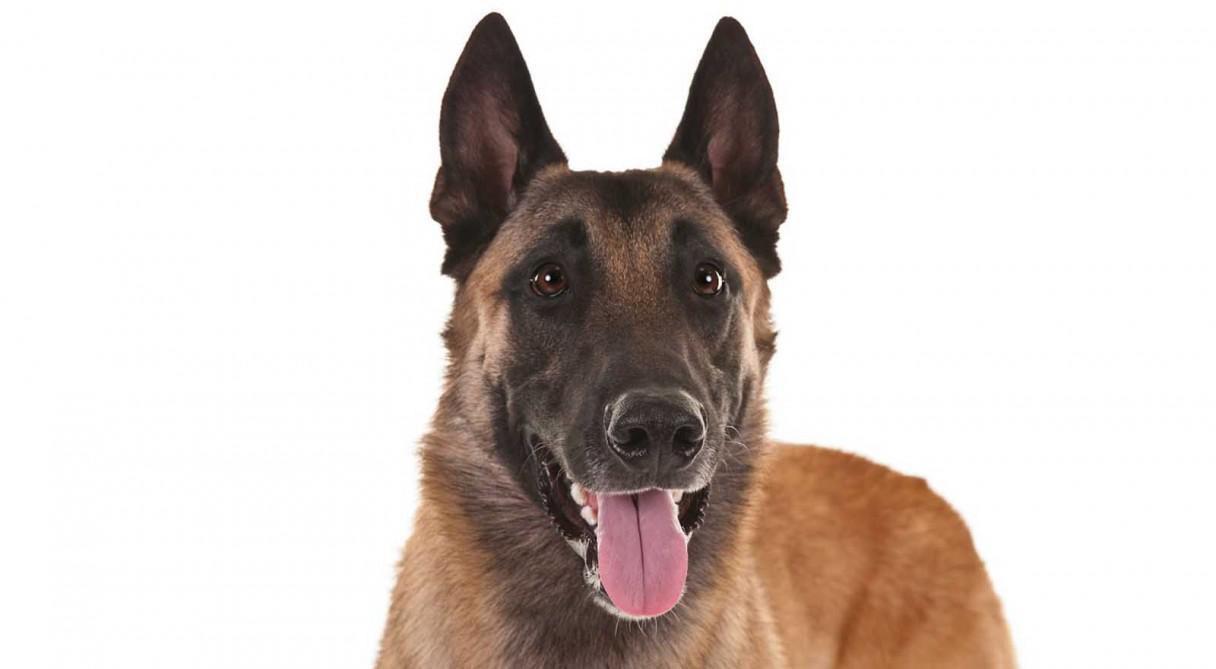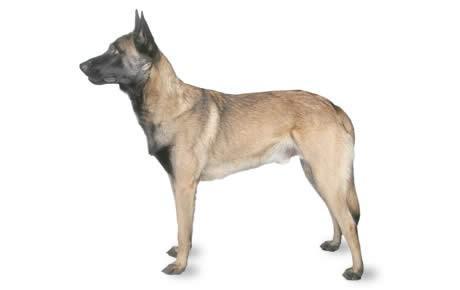The first image is the image on the left, the second image is the image on the right. Analyze the images presented: Is the assertion "One of the images contains a dog touching a blue collar." valid? Answer yes or no. No. The first image is the image on the left, the second image is the image on the right. Examine the images to the left and right. Is the description "An image shows one standing german shepherd facing leftward." accurate? Answer yes or no. Yes. 